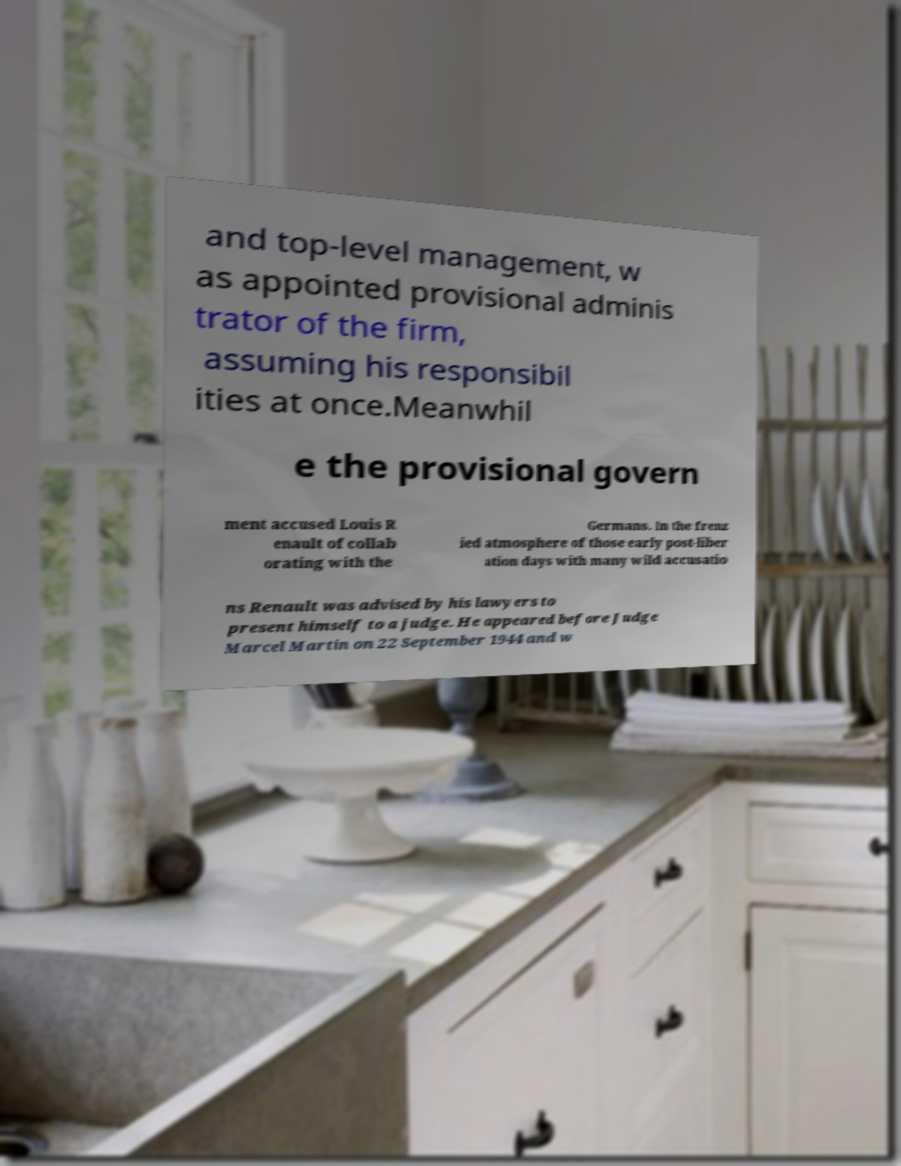For documentation purposes, I need the text within this image transcribed. Could you provide that? and top-level management, w as appointed provisional adminis trator of the firm, assuming his responsibil ities at once.Meanwhil e the provisional govern ment accused Louis R enault of collab orating with the Germans. In the frenz ied atmosphere of those early post-liber ation days with many wild accusatio ns Renault was advised by his lawyers to present himself to a judge. He appeared before Judge Marcel Martin on 22 September 1944 and w 